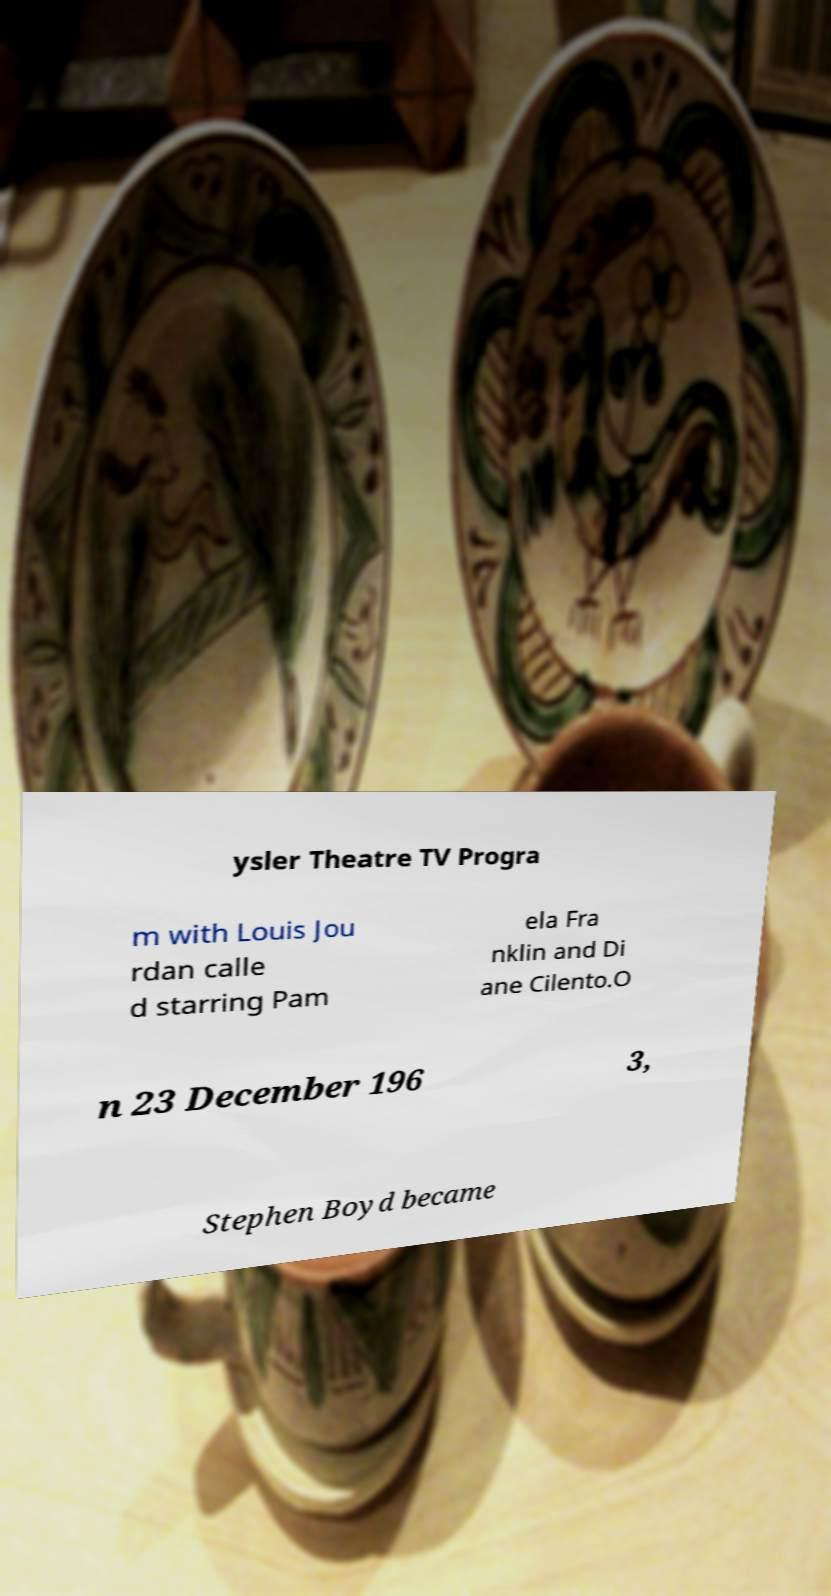Can you read and provide the text displayed in the image?This photo seems to have some interesting text. Can you extract and type it out for me? ysler Theatre TV Progra m with Louis Jou rdan calle d starring Pam ela Fra nklin and Di ane Cilento.O n 23 December 196 3, Stephen Boyd became 